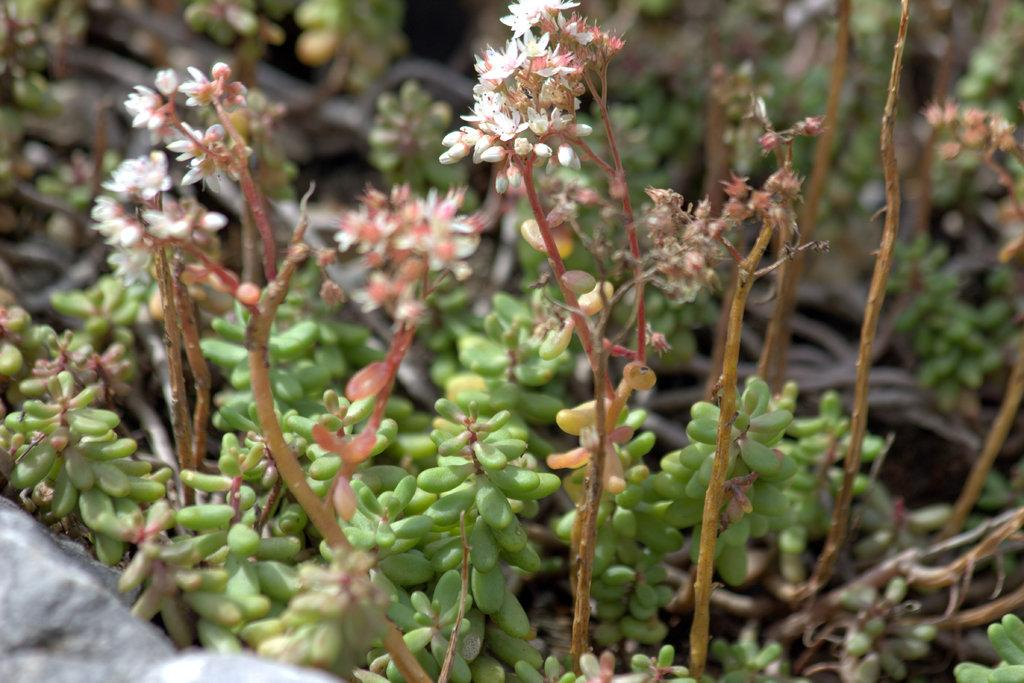What type of living organisms can be seen in the image? Plants can be seen in the image. What color are the flowers on the plants? The flowers on the plants have a white color. What color are the fruits on the plants? The fruits on the plants have a green color. Can you describe the background of the image? The background of the image is blurred. How does the image convey a sense of comfort to the viewer? The image does not convey a sense of comfort, as it only features plants with white flowers and green fruits against a blurred background. 